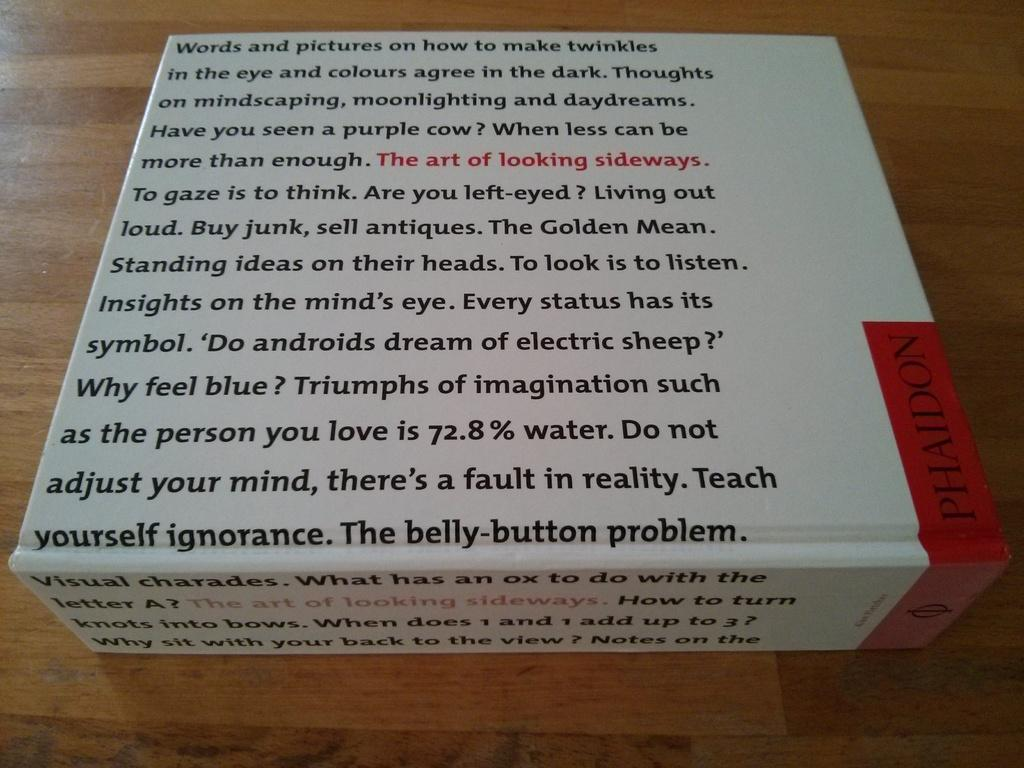<image>
Present a compact description of the photo's key features. A white box from Phaidon with a lot of print on it. 